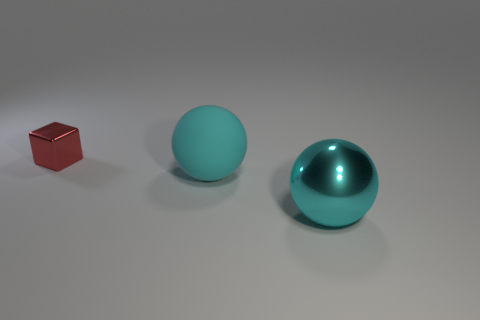Is there any other thing that is the same size as the metallic cube?
Ensure brevity in your answer.  No. There is a object that is to the left of the big metallic sphere and in front of the small red metal block; what shape is it?
Provide a short and direct response. Sphere. How many big yellow blocks have the same material as the red block?
Make the answer very short. 0. What number of tiny cubes are in front of the cyan ball that is behind the big cyan metallic thing?
Provide a succinct answer. 0. There is a large cyan thing right of the large sphere that is to the left of the metal object that is on the right side of the cyan rubber object; what is its shape?
Your answer should be very brief. Sphere. How many things are either cyan rubber spheres or big metal spheres?
Provide a short and direct response. 2. What color is the metallic sphere that is the same size as the rubber thing?
Ensure brevity in your answer.  Cyan. Does the big metallic object have the same shape as the metal object on the left side of the matte ball?
Your answer should be compact. No. How many things are either objects that are in front of the red cube or metallic things to the left of the metal ball?
Your response must be concise. 3. What is the shape of the large object that is the same color as the big metallic sphere?
Ensure brevity in your answer.  Sphere. 